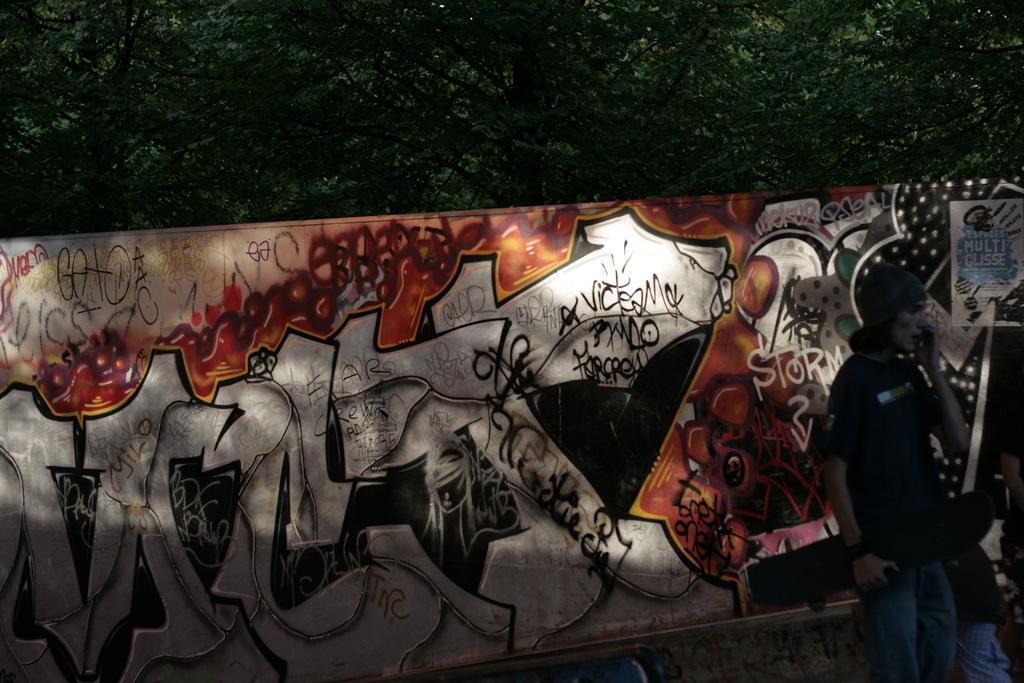Please provide a concise description of this image. A person is standing at the right wearing a cap and a black t shirt. Behind him there is an art wall. There are trees at the back. 